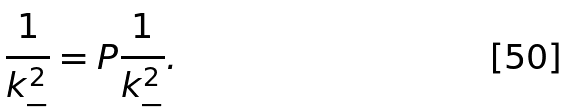<formula> <loc_0><loc_0><loc_500><loc_500>\frac { 1 } { k _ { - } ^ { 2 } } = P \frac { 1 } { k _ { - } ^ { 2 } } .</formula> 